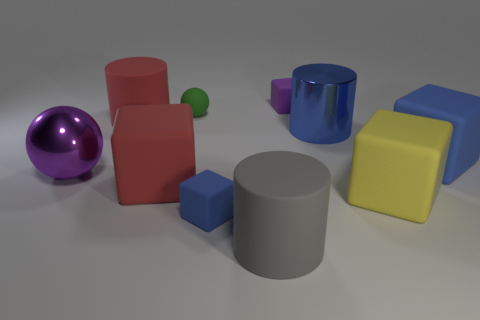Subtract all purple cubes. How many cubes are left? 4 Subtract all tiny purple blocks. How many blocks are left? 4 Subtract all brown blocks. Subtract all green cylinders. How many blocks are left? 5 Subtract all cylinders. How many objects are left? 7 Add 4 tiny purple objects. How many tiny purple objects exist? 5 Subtract 0 brown cubes. How many objects are left? 10 Subtract all spheres. Subtract all large purple balls. How many objects are left? 7 Add 6 tiny blue objects. How many tiny blue objects are left? 7 